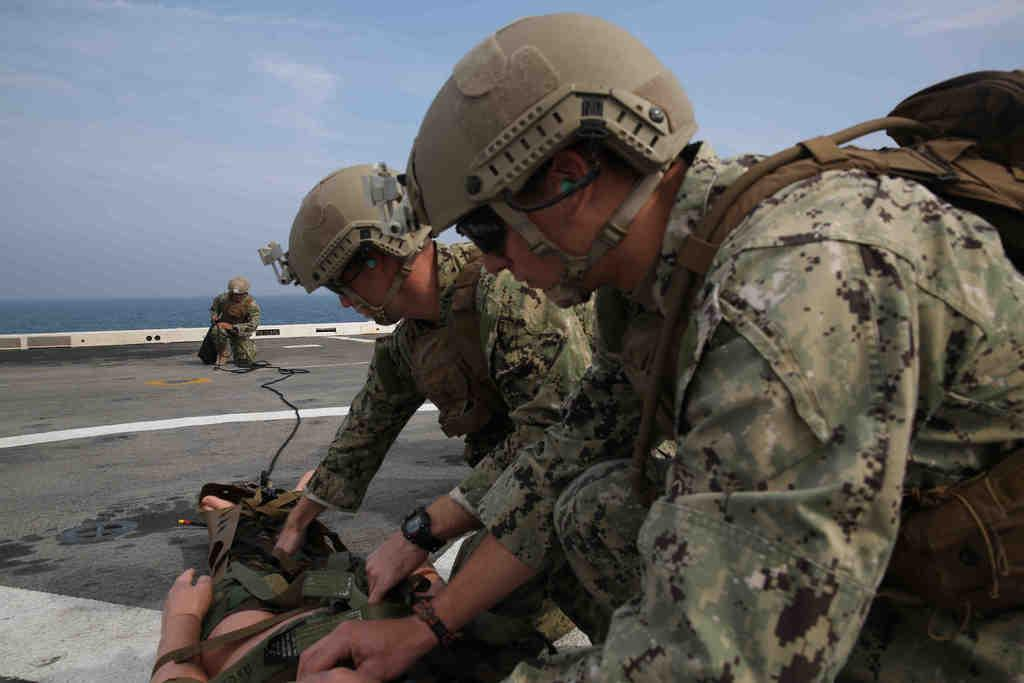Who are the people in the image? There are two combat medics in the image. What can be seen in the background of the image? There is a road and a lake in the image. What is visible in the sky in the image? The sky is visible in the image. What type of foot is visible in the image? There is no foot present in the image. How does the anger of the combat medics affect their performance in the image? There is no indication of anger in the image, and the combat medics' performance cannot be assessed based on the provided facts. 